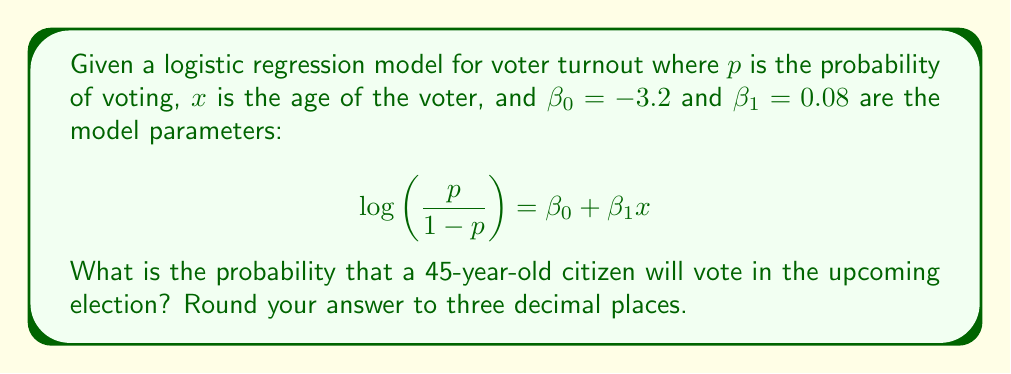Teach me how to tackle this problem. To solve this problem, we'll follow these steps:

1) We have the logistic regression model:
   $$\log\left(\frac{p}{1-p}\right) = \beta_0 + \beta_1x$$

2) We're given:
   $\beta_0 = -3.2$
   $\beta_1 = 0.08$
   $x = 45$ (age of the voter)

3) Let's substitute these values into our equation:
   $$\log\left(\frac{p}{1-p}\right) = -3.2 + 0.08(45)$$

4) Simplify:
   $$\log\left(\frac{p}{1-p}\right) = -3.2 + 3.6 = 0.4$$

5) Now, we need to solve for $p$. Let's start by exponentiating both sides:
   $$\frac{p}{1-p} = e^{0.4}$$

6) Calculate $e^{0.4}$:
   $$\frac{p}{1-p} \approx 1.4918$$

7) Now, let's solve for $p$:
   $$p = 1.4918(1-p)$$
   $$p = 1.4918 - 1.4918p$$
   $$2.4918p = 1.4918$$
   $$p = \frac{1.4918}{2.4918} \approx 0.5986$$

8) Rounding to three decimal places:
   $$p \approx 0.599$$
Answer: 0.599 